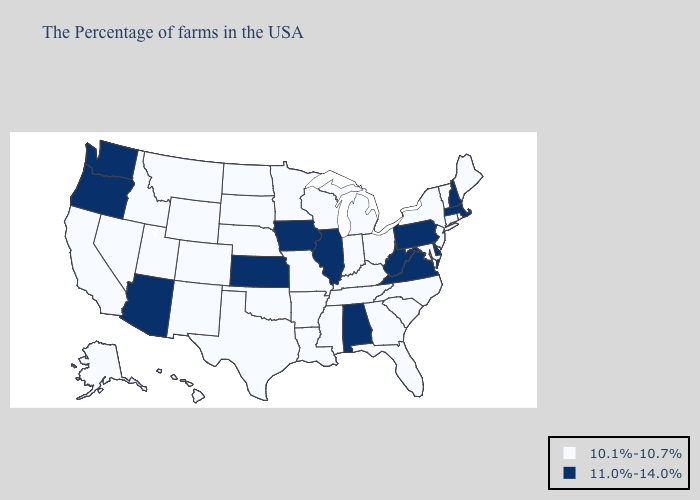Name the states that have a value in the range 11.0%-14.0%?
Concise answer only. Massachusetts, New Hampshire, Delaware, Pennsylvania, Virginia, West Virginia, Alabama, Illinois, Iowa, Kansas, Arizona, Washington, Oregon. Name the states that have a value in the range 10.1%-10.7%?
Quick response, please. Maine, Rhode Island, Vermont, Connecticut, New York, New Jersey, Maryland, North Carolina, South Carolina, Ohio, Florida, Georgia, Michigan, Kentucky, Indiana, Tennessee, Wisconsin, Mississippi, Louisiana, Missouri, Arkansas, Minnesota, Nebraska, Oklahoma, Texas, South Dakota, North Dakota, Wyoming, Colorado, New Mexico, Utah, Montana, Idaho, Nevada, California, Alaska, Hawaii. What is the lowest value in states that border Michigan?
Short answer required. 10.1%-10.7%. Name the states that have a value in the range 11.0%-14.0%?
Keep it brief. Massachusetts, New Hampshire, Delaware, Pennsylvania, Virginia, West Virginia, Alabama, Illinois, Iowa, Kansas, Arizona, Washington, Oregon. Name the states that have a value in the range 10.1%-10.7%?
Short answer required. Maine, Rhode Island, Vermont, Connecticut, New York, New Jersey, Maryland, North Carolina, South Carolina, Ohio, Florida, Georgia, Michigan, Kentucky, Indiana, Tennessee, Wisconsin, Mississippi, Louisiana, Missouri, Arkansas, Minnesota, Nebraska, Oklahoma, Texas, South Dakota, North Dakota, Wyoming, Colorado, New Mexico, Utah, Montana, Idaho, Nevada, California, Alaska, Hawaii. How many symbols are there in the legend?
Concise answer only. 2. What is the value of West Virginia?
Short answer required. 11.0%-14.0%. Which states have the lowest value in the USA?
Keep it brief. Maine, Rhode Island, Vermont, Connecticut, New York, New Jersey, Maryland, North Carolina, South Carolina, Ohio, Florida, Georgia, Michigan, Kentucky, Indiana, Tennessee, Wisconsin, Mississippi, Louisiana, Missouri, Arkansas, Minnesota, Nebraska, Oklahoma, Texas, South Dakota, North Dakota, Wyoming, Colorado, New Mexico, Utah, Montana, Idaho, Nevada, California, Alaska, Hawaii. What is the lowest value in the USA?
Keep it brief. 10.1%-10.7%. What is the lowest value in the West?
Answer briefly. 10.1%-10.7%. Does Michigan have the lowest value in the USA?
Be succinct. Yes. Which states have the highest value in the USA?
Keep it brief. Massachusetts, New Hampshire, Delaware, Pennsylvania, Virginia, West Virginia, Alabama, Illinois, Iowa, Kansas, Arizona, Washington, Oregon. What is the value of Texas?
Short answer required. 10.1%-10.7%. What is the lowest value in the South?
Concise answer only. 10.1%-10.7%. Which states have the lowest value in the South?
Give a very brief answer. Maryland, North Carolina, South Carolina, Florida, Georgia, Kentucky, Tennessee, Mississippi, Louisiana, Arkansas, Oklahoma, Texas. 